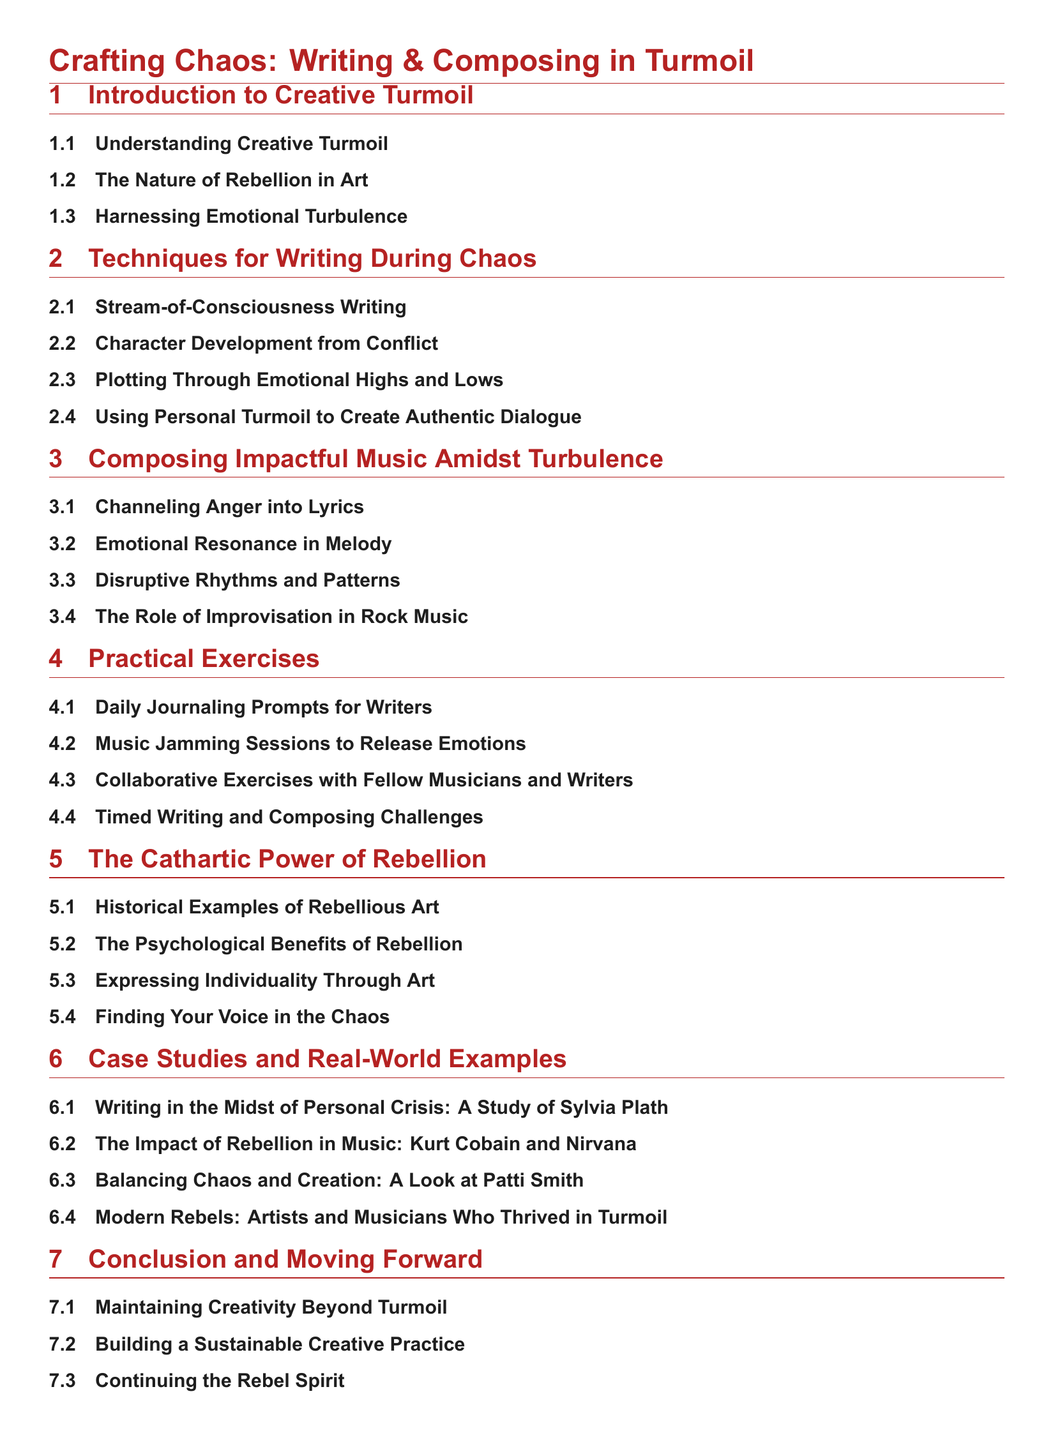What is the main title of the document? The main title is presented at the top of the table of contents, summarizing the overall theme of the document.
Answer: Crafting Chaos: Writing & Composing in Turmoil How many sections are in the document? To determine the number of sections, we count the primary headings listed in the table of contents.
Answer: 6 What is the first subsection under "Techniques for Writing During Chaos"? The first subsection provides specific writing techniques when faced with chaotic situations.
Answer: Stream-of-Consciousness Writing Which artist is studied in the case study about rebellion in music? This question refers to a specific subsection that covers the impact of a well-known musician's rebellion.
Answer: Kurt Cobain and Nirvana What activity is suggested for emotional release in practical exercises? This question points to a specific practical exercise that encourages collaboration and emotional expression through music.
Answer: Music Jamming Sessions to Release Emotions What psychological aspect is explored in the section about rebellion? This involves understanding the benefits associated with the rebellious spirit within the context of art and creativity.
Answer: The Psychological Benefits of Rebellion 